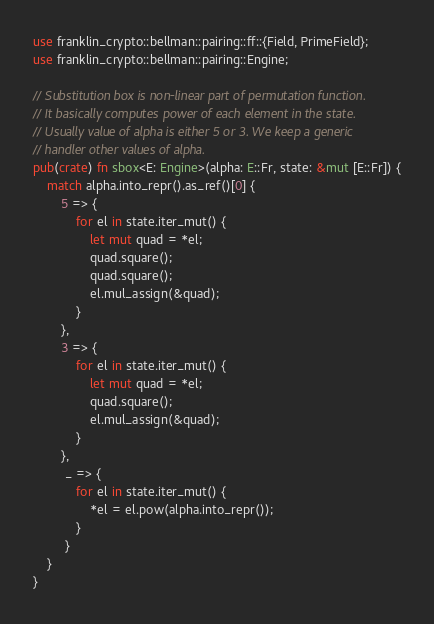<code> <loc_0><loc_0><loc_500><loc_500><_Rust_>use franklin_crypto::bellman::pairing::ff::{Field, PrimeField};
use franklin_crypto::bellman::pairing::Engine;

// Substitution box is non-linear part of permutation function.
// It basically computes power of each element in the state.
// Usually value of alpha is either 5 or 3. We keep a generic 
// handler other values of alpha. 
pub(crate) fn sbox<E: Engine>(alpha: E::Fr, state: &mut [E::Fr]) {
    match alpha.into_repr().as_ref()[0] {
        5 => {
            for el in state.iter_mut() {
                let mut quad = *el;
                quad.square();
                quad.square();
                el.mul_assign(&quad);
            }
        },
        3 => {
            for el in state.iter_mut() {
                let mut quad = *el;
                quad.square();
                el.mul_assign(&quad);
            }
        },
         _ => {
            for el in state.iter_mut() {
                *el = el.pow(alpha.into_repr());
            }
         }
    }
}
</code> 